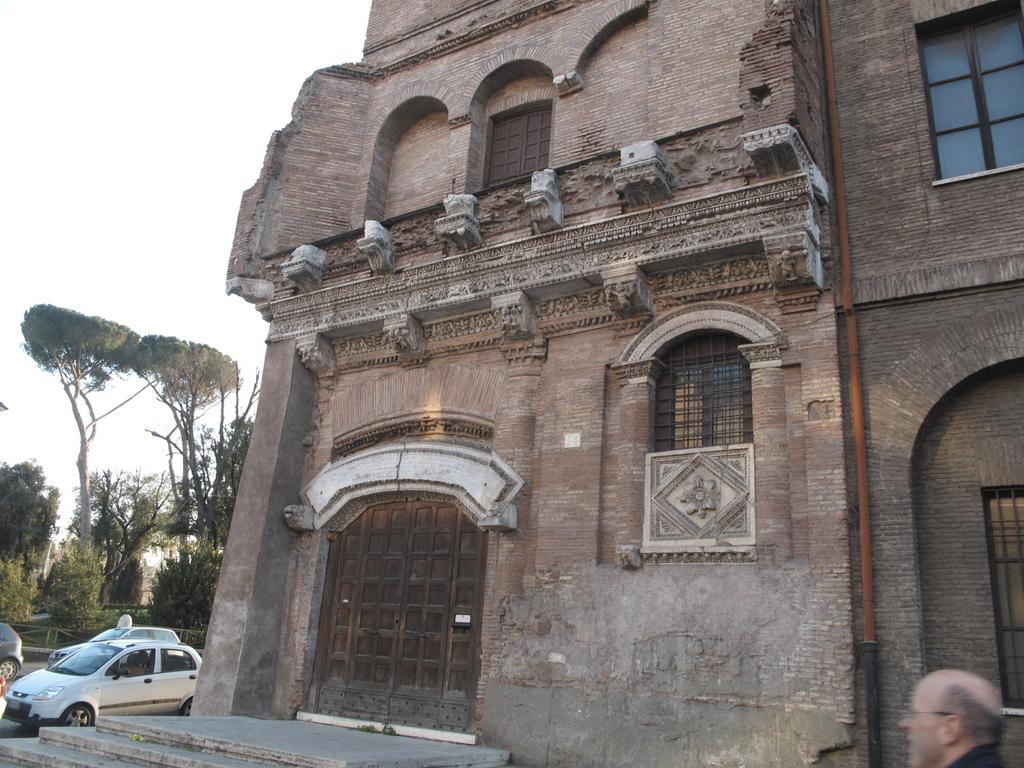What type of structure is present in the image? There is a building in the image. What else can be seen in the image besides the building? There are cars, trees, the sky, stairs, and a person in the image. Can you describe the natural elements in the background of the image? There are trees and the sky visible in the background of the image. What architectural feature is present at the bottom of the image? There are stairs at the bottom of the image. Who or what is present in the image along with the building and other elements? There is a person in the image. Where is the jail located in the image? There is no jail present in the image. What type of tub can be seen in the image? There is no tub present in the image. 